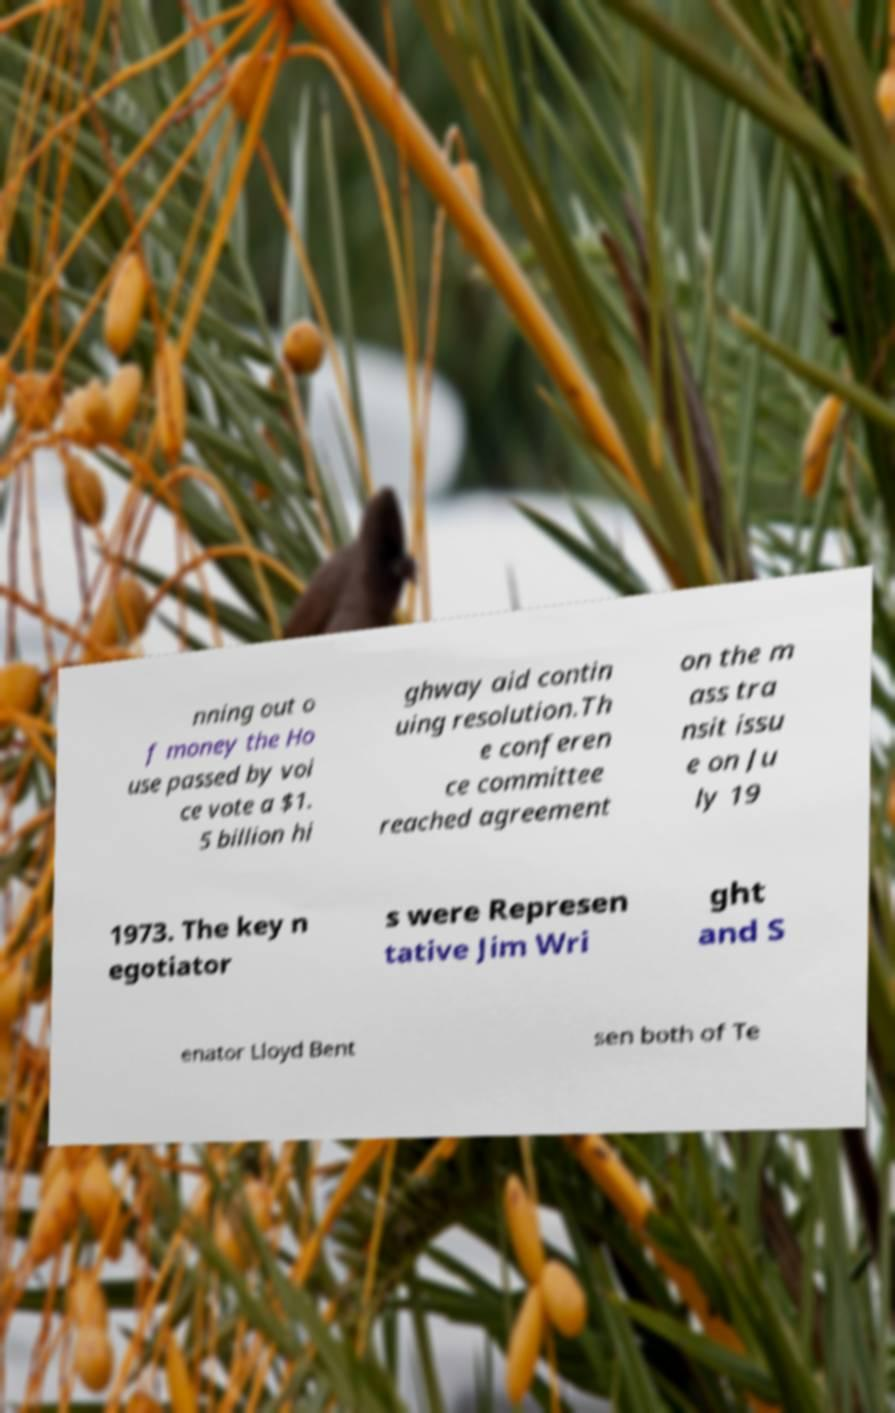Please read and relay the text visible in this image. What does it say? nning out o f money the Ho use passed by voi ce vote a $1. 5 billion hi ghway aid contin uing resolution.Th e conferen ce committee reached agreement on the m ass tra nsit issu e on Ju ly 19 1973. The key n egotiator s were Represen tative Jim Wri ght and S enator Lloyd Bent sen both of Te 